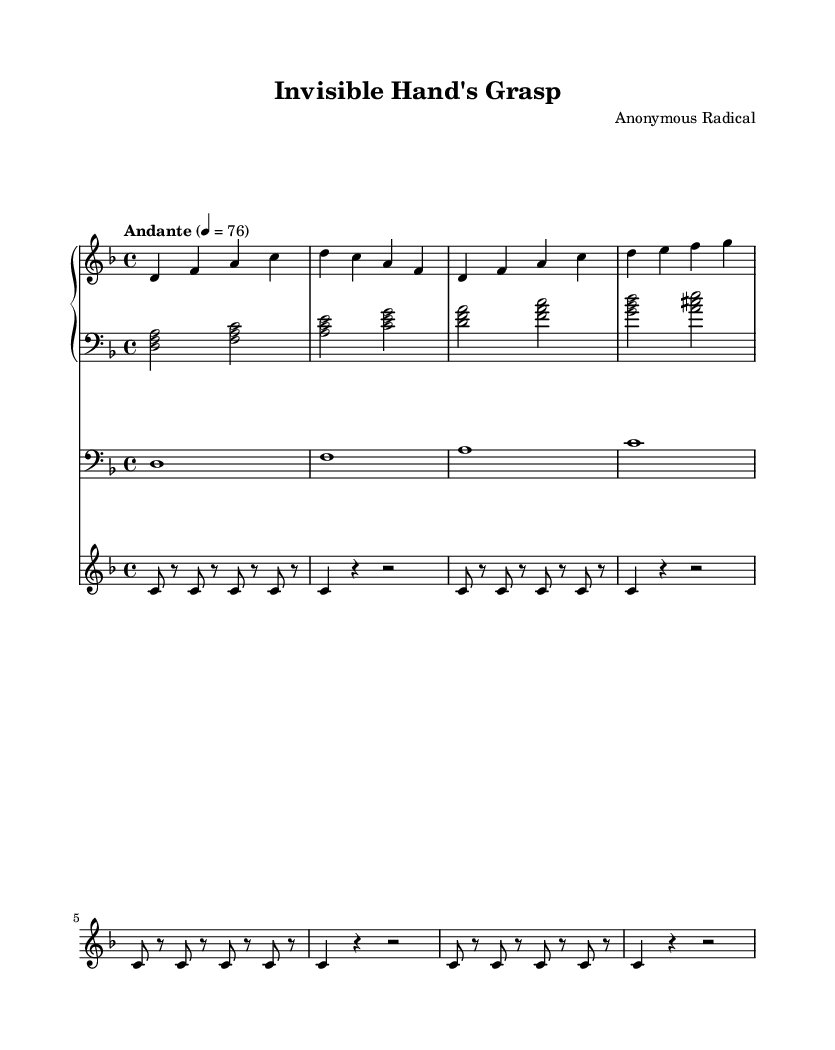What is the key signature of this music? The key signature is D minor, which contains one flat (B flat) indicated at the beginning of the staff.
Answer: D minor What is the time signature of this composition? The time signature is 4/4, which is shown at the beginning of the music, indicating four beats per measure.
Answer: 4/4 What is the tempo indication for this piece? The tempo is marked "Andante" at quarter note equals 76, suggesting a moderate pace.
Answer: Andante How many measures are in the right hand piano part? The right hand piano part has four measures, which can be counted from the beginning to where it ends.
Answer: 4 What is the instrument indicated for the cello part? The cello part is specifically designated with a clef indicating it is written for cello, and the instrument is labeled as such.
Answer: Cello Which two instruments are used in the accompaniment of this piece? The accompaniment includes piano (both right and left hands) and vibraphone, which are named in the score.
Answer: Piano and vibraphone What is the significance of the repeated note pattern in the vibraphone part? The repeated note pattern in the vibraphone section indicates a minimalist technique, creating a layering effect that emphasizes a meditative quality, relevant to the introspective themes in films critiquing neoliberal economics.
Answer: Minimalist technique 